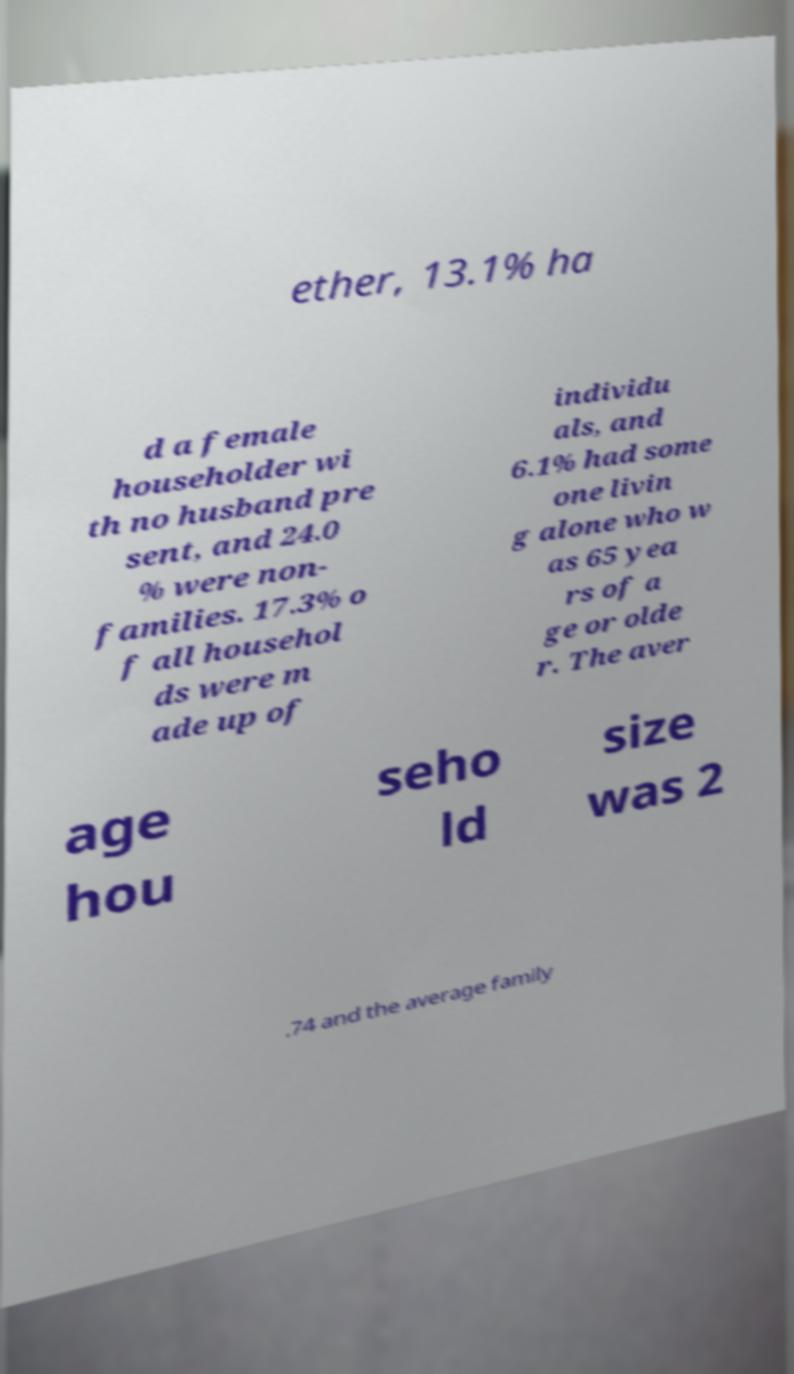Can you accurately transcribe the text from the provided image for me? ether, 13.1% ha d a female householder wi th no husband pre sent, and 24.0 % were non- families. 17.3% o f all househol ds were m ade up of individu als, and 6.1% had some one livin g alone who w as 65 yea rs of a ge or olde r. The aver age hou seho ld size was 2 .74 and the average family 